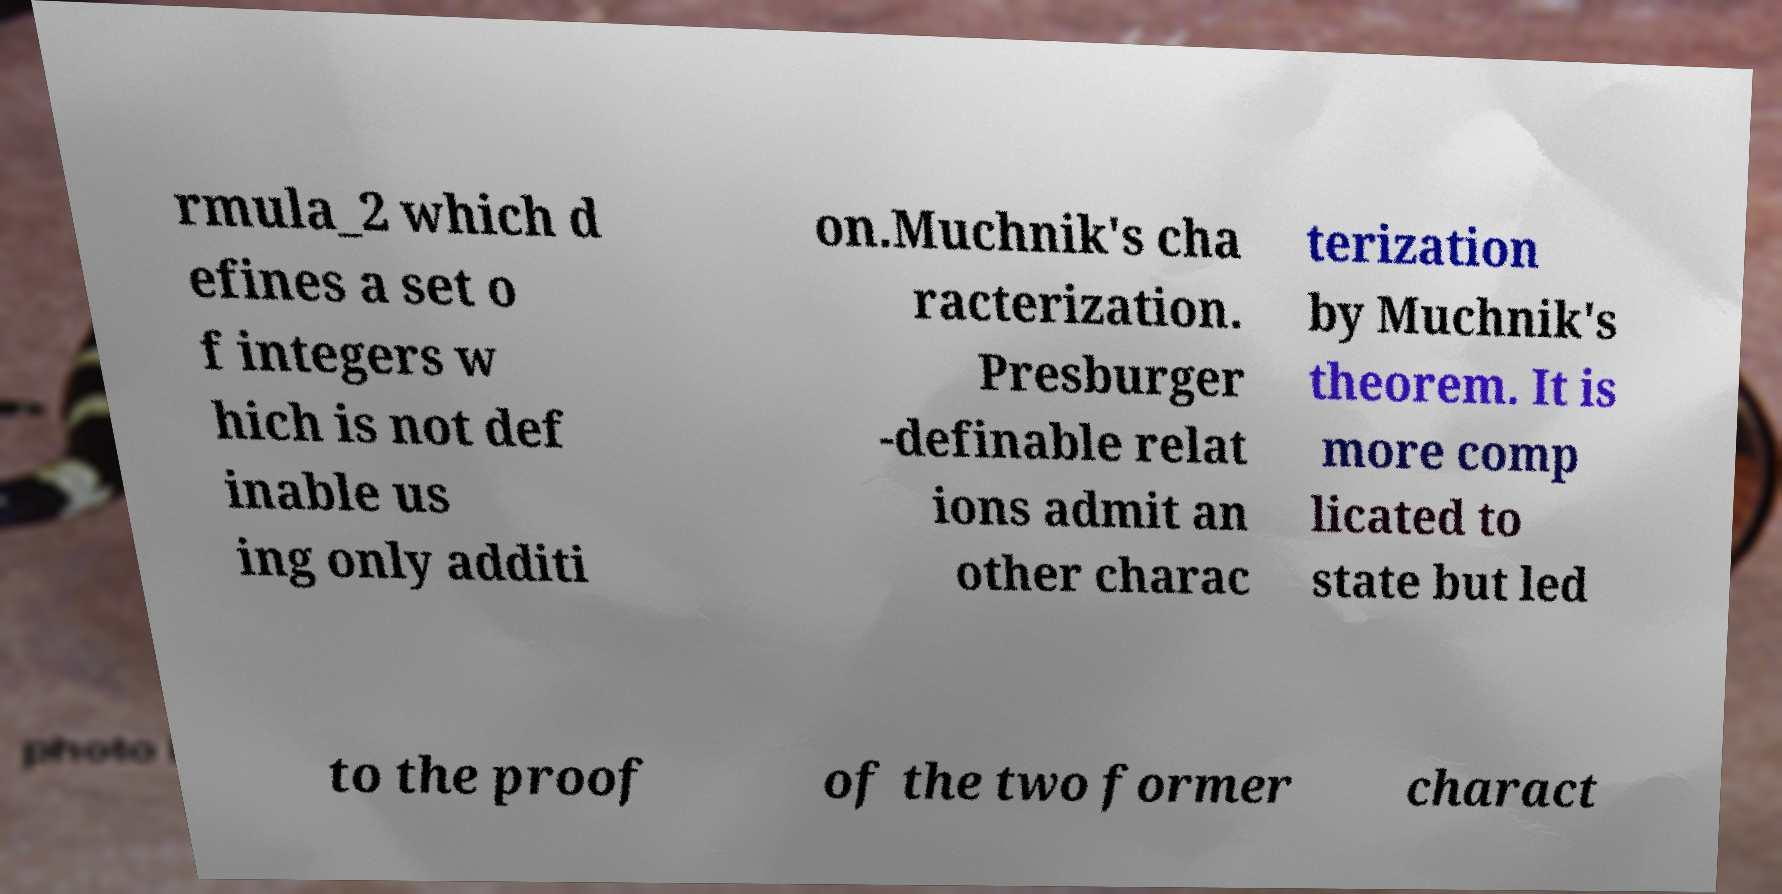For documentation purposes, I need the text within this image transcribed. Could you provide that? rmula_2 which d efines a set o f integers w hich is not def inable us ing only additi on.Muchnik's cha racterization. Presburger -definable relat ions admit an other charac terization by Muchnik's theorem. It is more comp licated to state but led to the proof of the two former charact 